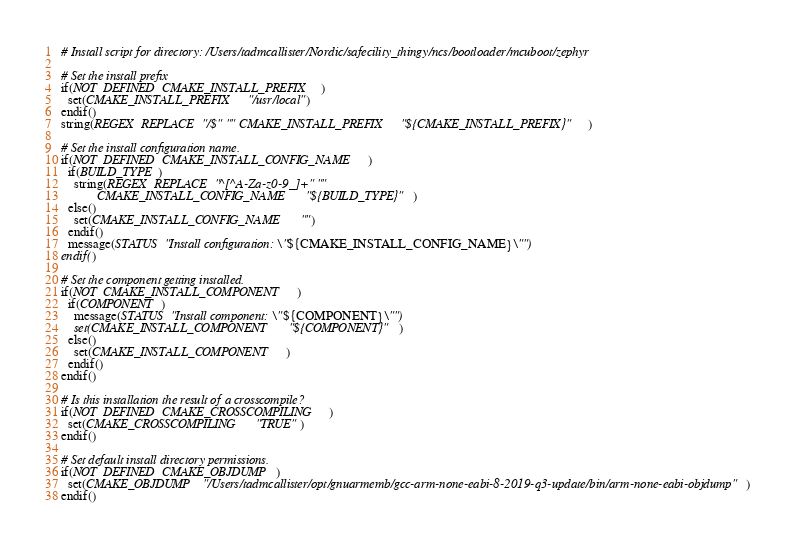Convert code to text. <code><loc_0><loc_0><loc_500><loc_500><_CMake_># Install script for directory: /Users/tadmcallister/Nordic/safecility_thingy/ncs/bootloader/mcuboot/zephyr

# Set the install prefix
if(NOT DEFINED CMAKE_INSTALL_PREFIX)
  set(CMAKE_INSTALL_PREFIX "/usr/local")
endif()
string(REGEX REPLACE "/$" "" CMAKE_INSTALL_PREFIX "${CMAKE_INSTALL_PREFIX}")

# Set the install configuration name.
if(NOT DEFINED CMAKE_INSTALL_CONFIG_NAME)
  if(BUILD_TYPE)
    string(REGEX REPLACE "^[^A-Za-z0-9_]+" ""
           CMAKE_INSTALL_CONFIG_NAME "${BUILD_TYPE}")
  else()
    set(CMAKE_INSTALL_CONFIG_NAME "")
  endif()
  message(STATUS "Install configuration: \"${CMAKE_INSTALL_CONFIG_NAME}\"")
endif()

# Set the component getting installed.
if(NOT CMAKE_INSTALL_COMPONENT)
  if(COMPONENT)
    message(STATUS "Install component: \"${COMPONENT}\"")
    set(CMAKE_INSTALL_COMPONENT "${COMPONENT}")
  else()
    set(CMAKE_INSTALL_COMPONENT)
  endif()
endif()

# Is this installation the result of a crosscompile?
if(NOT DEFINED CMAKE_CROSSCOMPILING)
  set(CMAKE_CROSSCOMPILING "TRUE")
endif()

# Set default install directory permissions.
if(NOT DEFINED CMAKE_OBJDUMP)
  set(CMAKE_OBJDUMP "/Users/tadmcallister/opt/gnuarmemb/gcc-arm-none-eabi-8-2019-q3-update/bin/arm-none-eabi-objdump")
endif()

</code> 